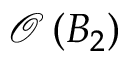<formula> <loc_0><loc_0><loc_500><loc_500>\mathcal { O } \left ( B _ { 2 } \right )</formula> 